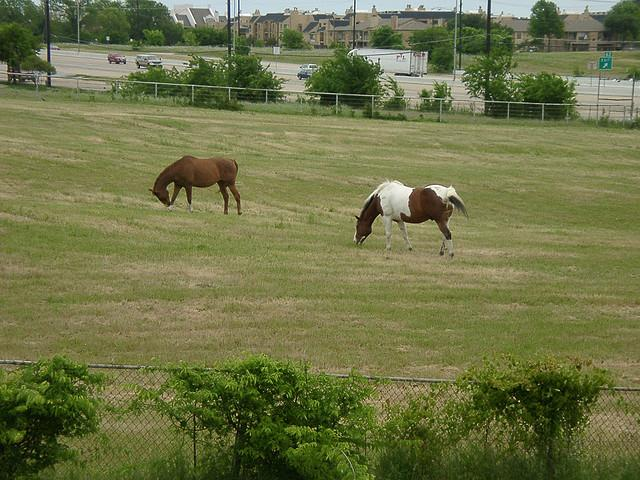What type of animals are present? Please explain your reasoning. horse. Two large animals with manes and long snouts grazing in the grasses. 